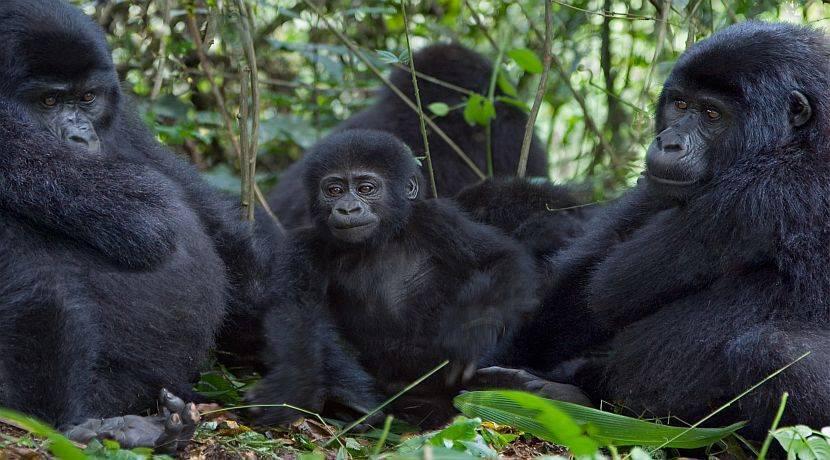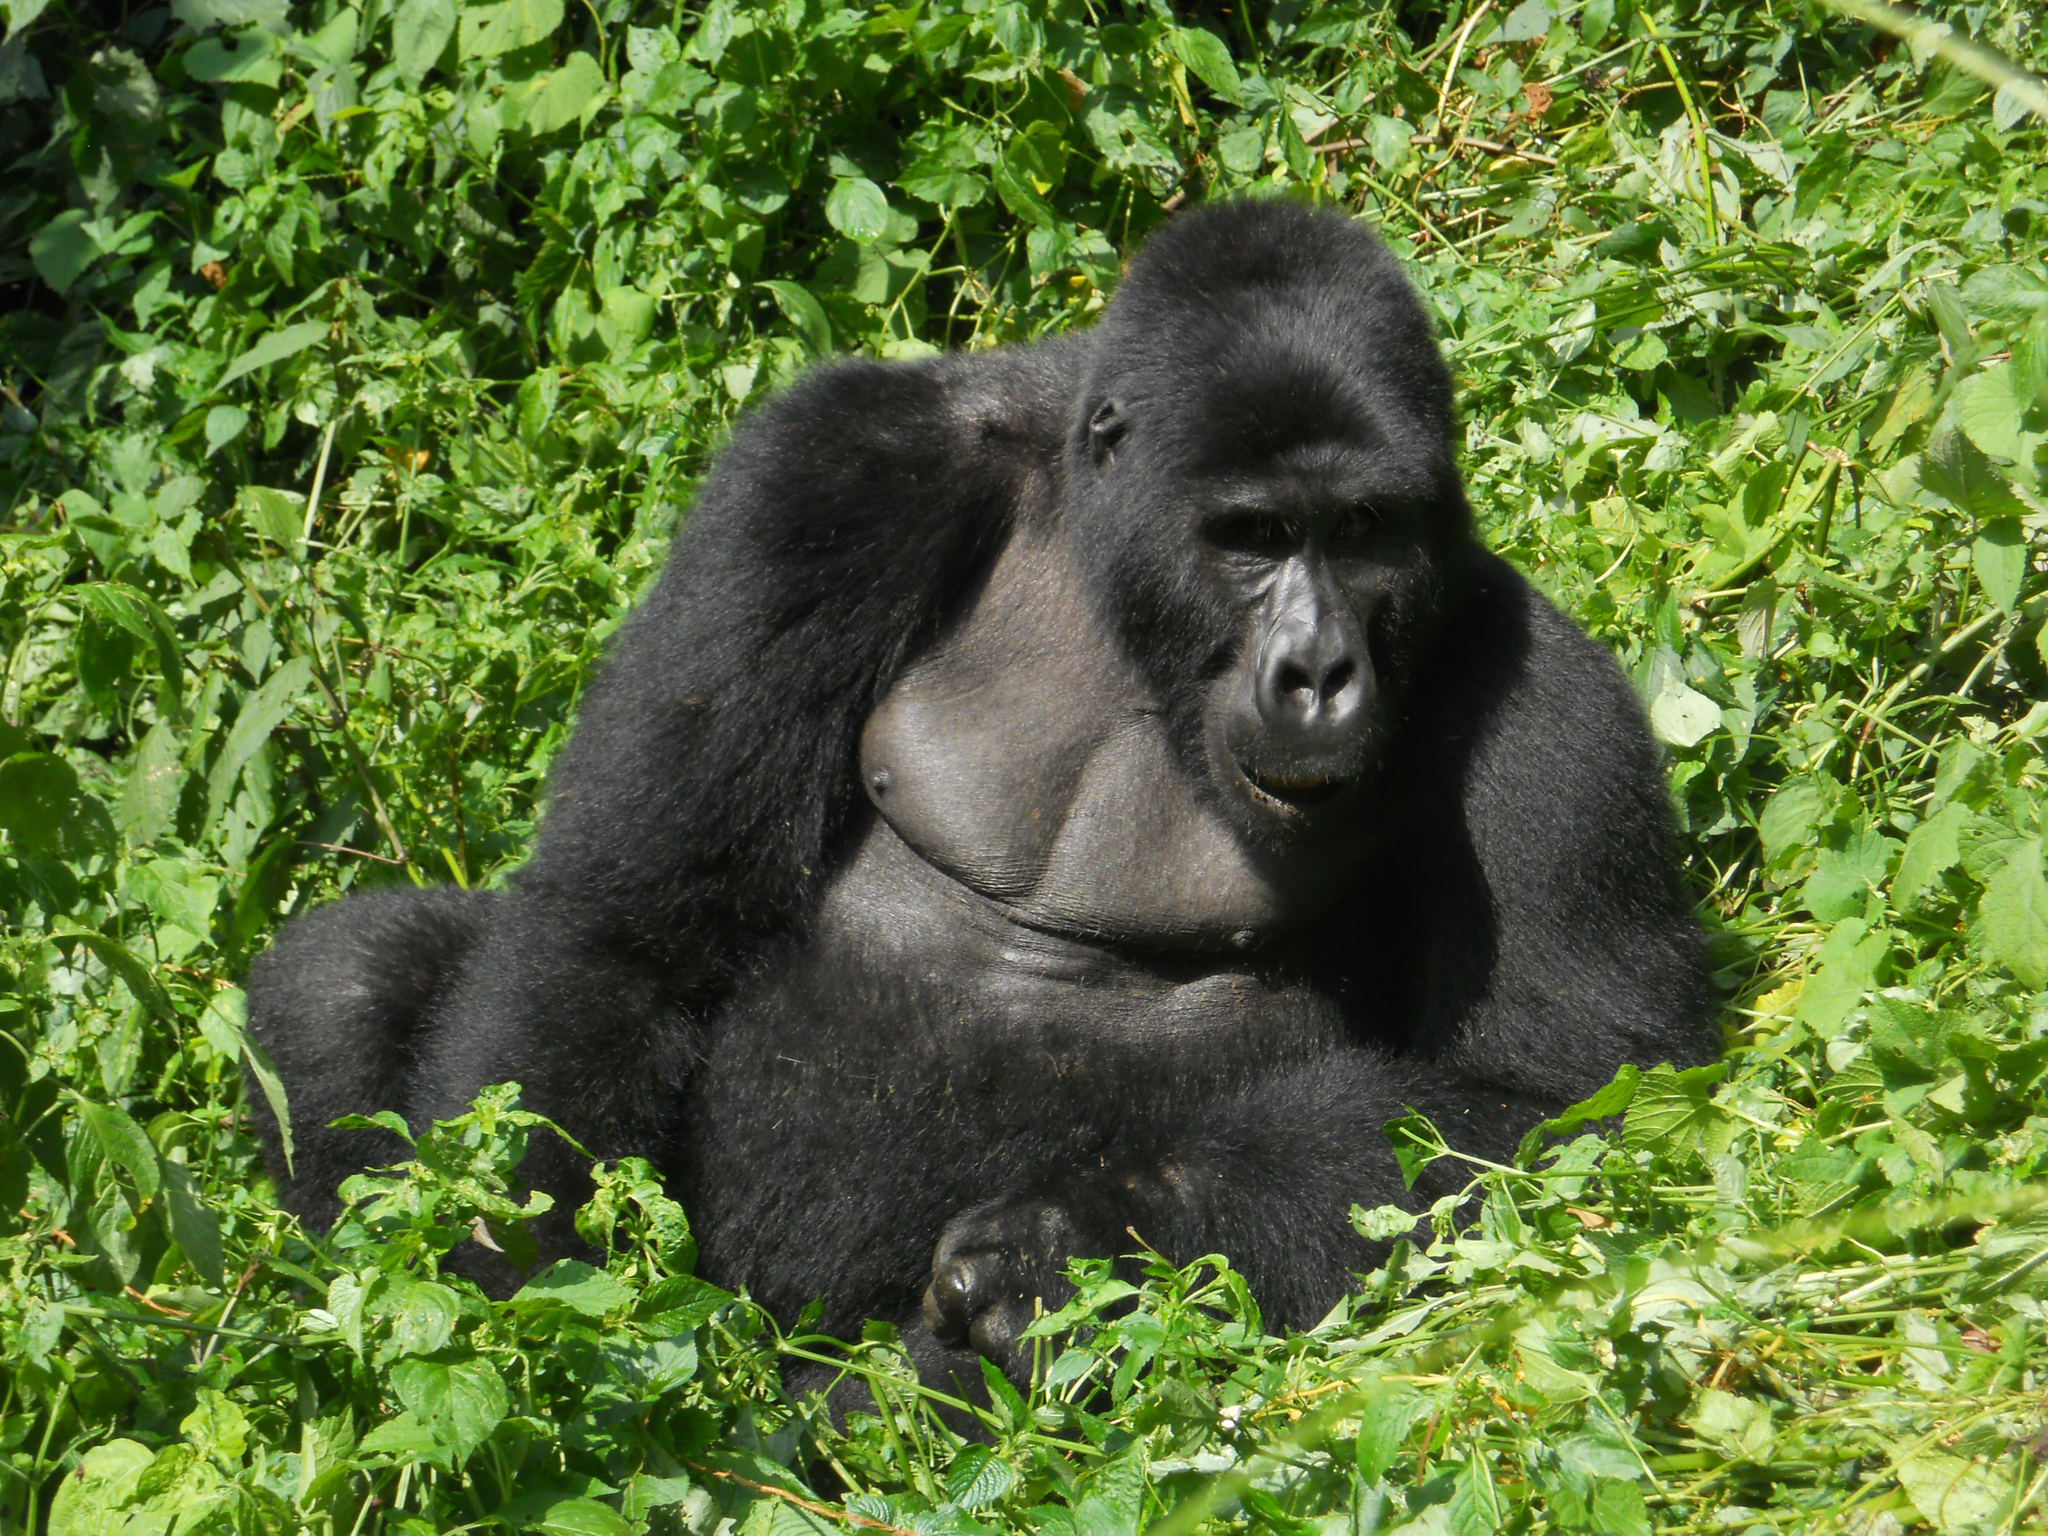The first image is the image on the left, the second image is the image on the right. Assess this claim about the two images: "One of the images shows at least one gorilla standing on its hands.". Correct or not? Answer yes or no. No. The first image is the image on the left, the second image is the image on the right. Examine the images to the left and right. Is the description "Right image shows one foreground family-type gorilla group, which includes young gorillas." accurate? Answer yes or no. No. 